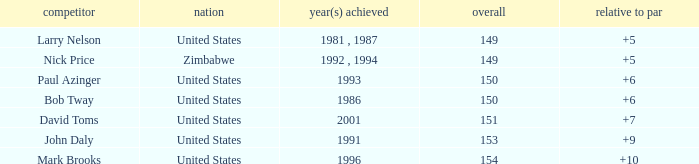What is the total for 1986 with a to par higher than 6? 0.0. 